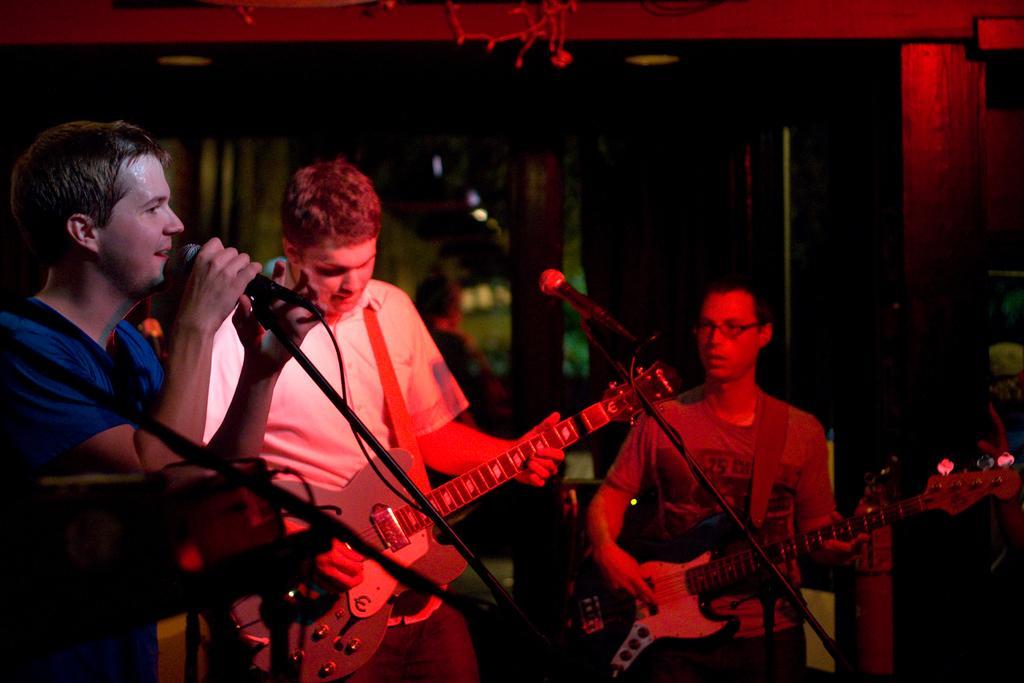In one or two sentences, can you explain what this image depicts? In this image I can see three persons are standing holding musical instruments and microphone in their hands. I can see few microphones, few wooden poles and the dark background. 